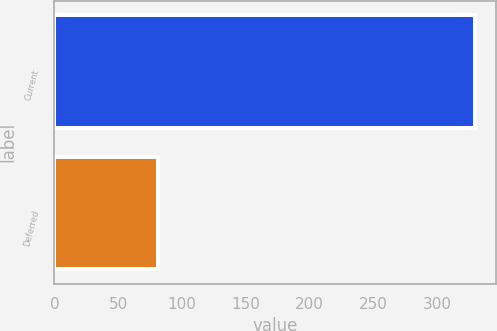<chart> <loc_0><loc_0><loc_500><loc_500><bar_chart><fcel>Current<fcel>Deferred<nl><fcel>330<fcel>81<nl></chart> 